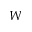Convert formula to latex. <formula><loc_0><loc_0><loc_500><loc_500>W</formula> 